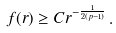<formula> <loc_0><loc_0><loc_500><loc_500>f ( r ) \geq C r ^ { - \frac { 1 } { 2 ( p - 1 ) } } \, .</formula> 